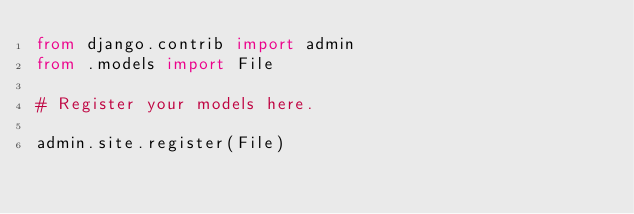<code> <loc_0><loc_0><loc_500><loc_500><_Python_>from django.contrib import admin
from .models import File

# Register your models here.

admin.site.register(File)
</code> 